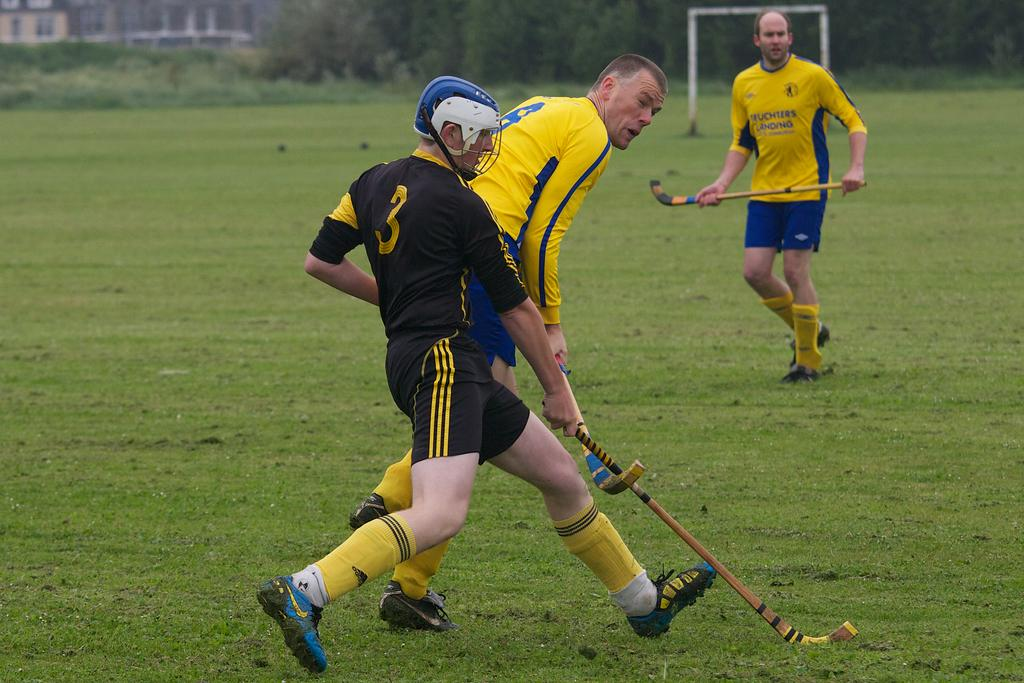<image>
Relay a brief, clear account of the picture shown. Number 3 and number 8 try and out manuever each other for the ball. 